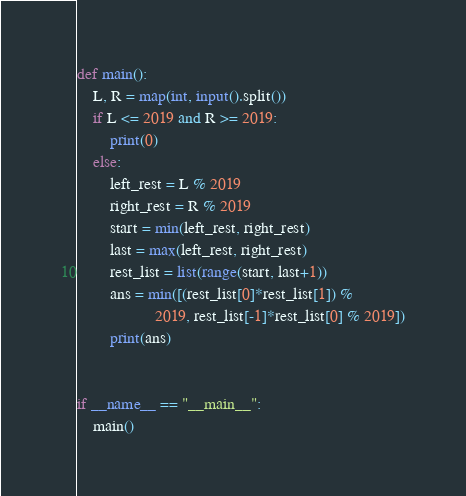Convert code to text. <code><loc_0><loc_0><loc_500><loc_500><_Python_>def main():
    L, R = map(int, input().split())
    if L <= 2019 and R >= 2019:
        print(0)
    else:
        left_rest = L % 2019
        right_rest = R % 2019
        start = min(left_rest, right_rest)
        last = max(left_rest, right_rest)
        rest_list = list(range(start, last+1))
        ans = min([(rest_list[0]*rest_list[1]) %
                   2019, rest_list[-1]*rest_list[0] % 2019])
        print(ans)


if __name__ == "__main__":
    main()
</code> 